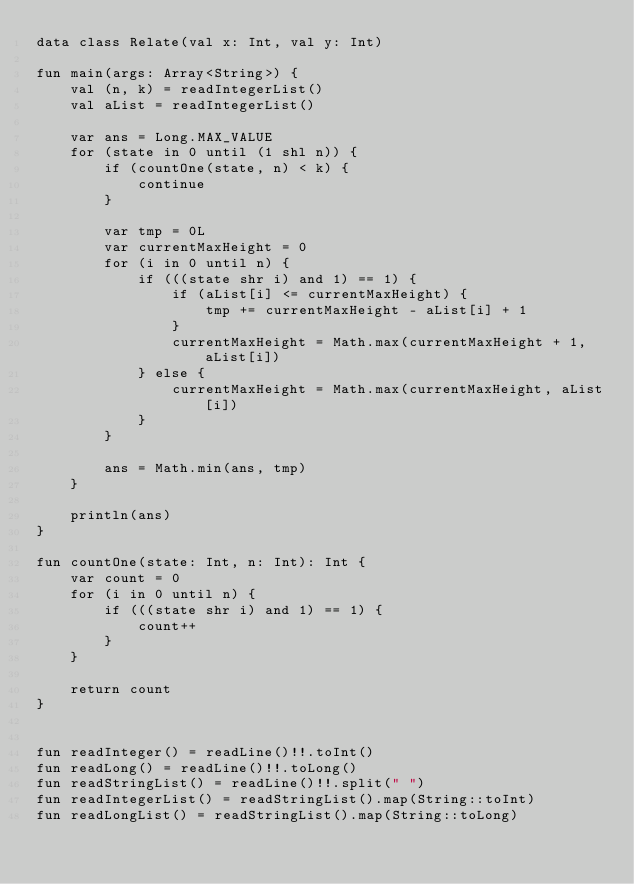Convert code to text. <code><loc_0><loc_0><loc_500><loc_500><_Kotlin_>data class Relate(val x: Int, val y: Int)

fun main(args: Array<String>) {
    val (n, k) = readIntegerList()
    val aList = readIntegerList()

    var ans = Long.MAX_VALUE
    for (state in 0 until (1 shl n)) {
        if (countOne(state, n) < k) {
            continue
        }

        var tmp = 0L
        var currentMaxHeight = 0
        for (i in 0 until n) {
            if (((state shr i) and 1) == 1) {
                if (aList[i] <= currentMaxHeight) {
                    tmp += currentMaxHeight - aList[i] + 1
                }
                currentMaxHeight = Math.max(currentMaxHeight + 1, aList[i])
            } else {
                currentMaxHeight = Math.max(currentMaxHeight, aList[i])
            }
        }

        ans = Math.min(ans, tmp)
    }

    println(ans)
}

fun countOne(state: Int, n: Int): Int {
    var count = 0
    for (i in 0 until n) {
        if (((state shr i) and 1) == 1) {
            count++
        }
    }

    return count
}


fun readInteger() = readLine()!!.toInt()
fun readLong() = readLine()!!.toLong()
fun readStringList() = readLine()!!.split(" ")
fun readIntegerList() = readStringList().map(String::toInt)
fun readLongList() = readStringList().map(String::toLong)
</code> 